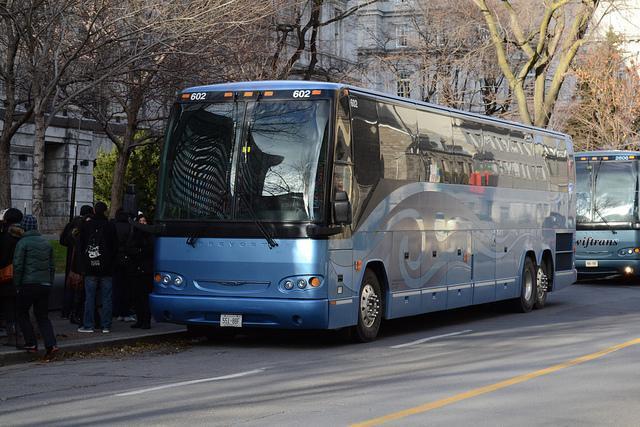How many tires are there?
Give a very brief answer. 3. How many people are there?
Give a very brief answer. 5. How many buses are there?
Give a very brief answer. 2. 